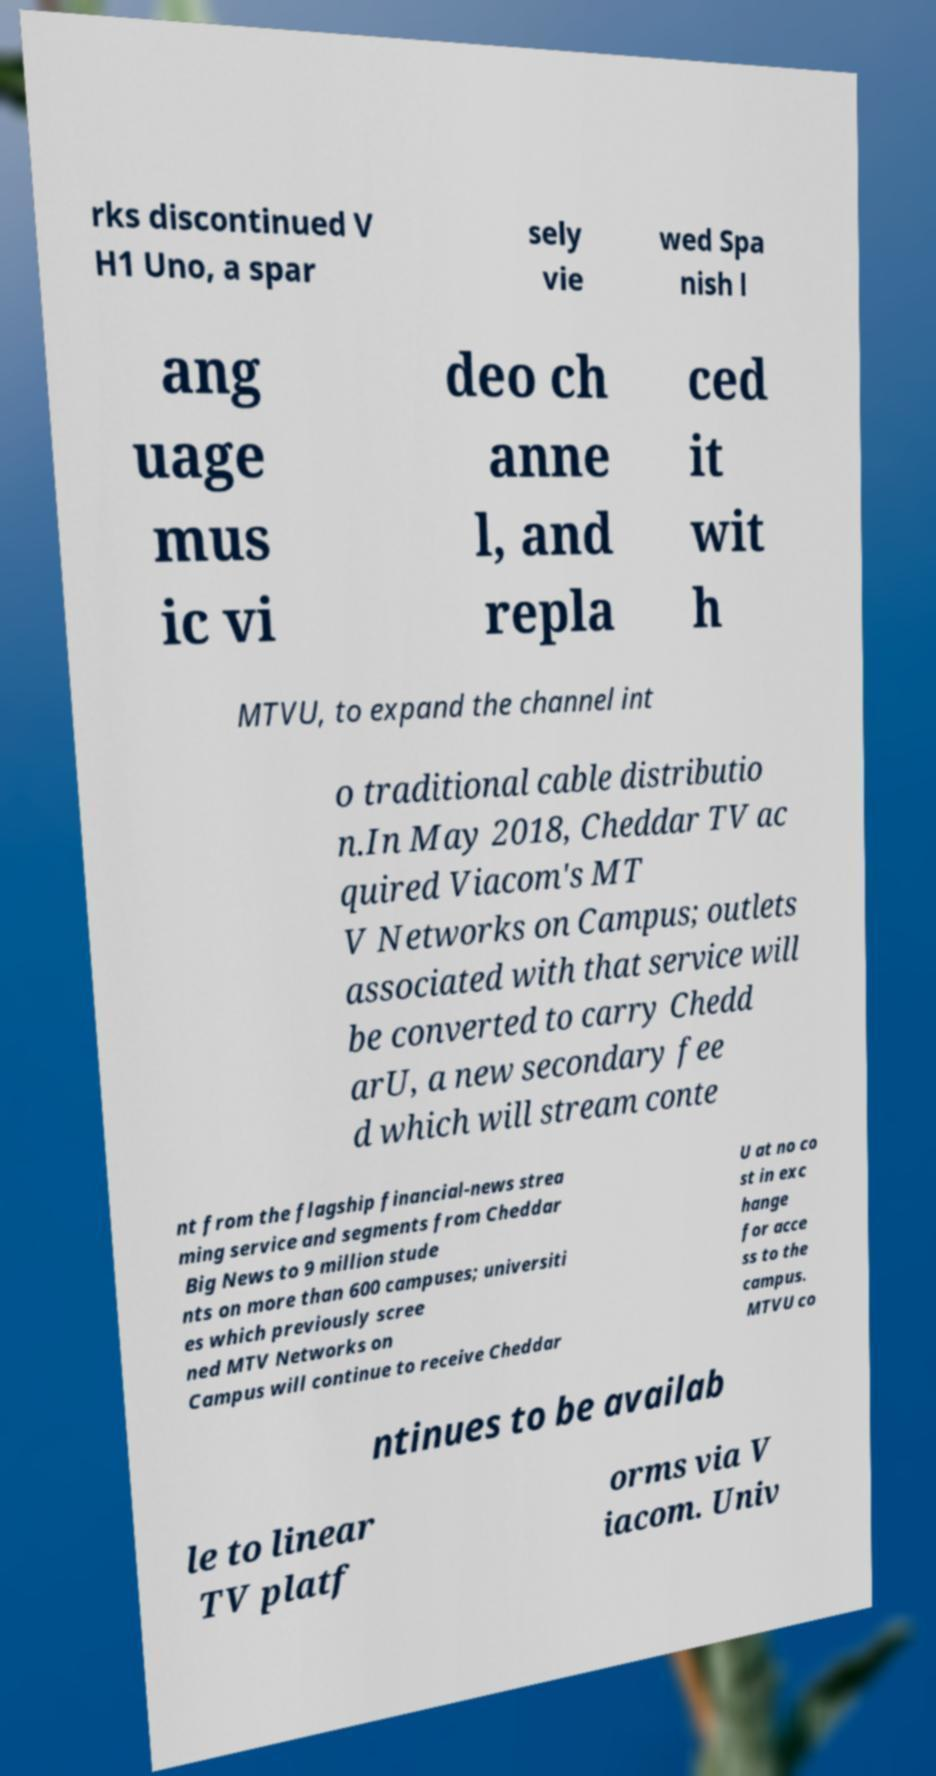What messages or text are displayed in this image? I need them in a readable, typed format. rks discontinued V H1 Uno, a spar sely vie wed Spa nish l ang uage mus ic vi deo ch anne l, and repla ced it wit h MTVU, to expand the channel int o traditional cable distributio n.In May 2018, Cheddar TV ac quired Viacom's MT V Networks on Campus; outlets associated with that service will be converted to carry Chedd arU, a new secondary fee d which will stream conte nt from the flagship financial-news strea ming service and segments from Cheddar Big News to 9 million stude nts on more than 600 campuses; universiti es which previously scree ned MTV Networks on Campus will continue to receive Cheddar U at no co st in exc hange for acce ss to the campus. MTVU co ntinues to be availab le to linear TV platf orms via V iacom. Univ 